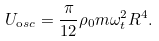Convert formula to latex. <formula><loc_0><loc_0><loc_500><loc_500>U _ { \mathrm o s c } = \frac { \pi } { 1 2 } \rho _ { 0 } m \omega _ { t } ^ { 2 } R ^ { 4 } .</formula> 